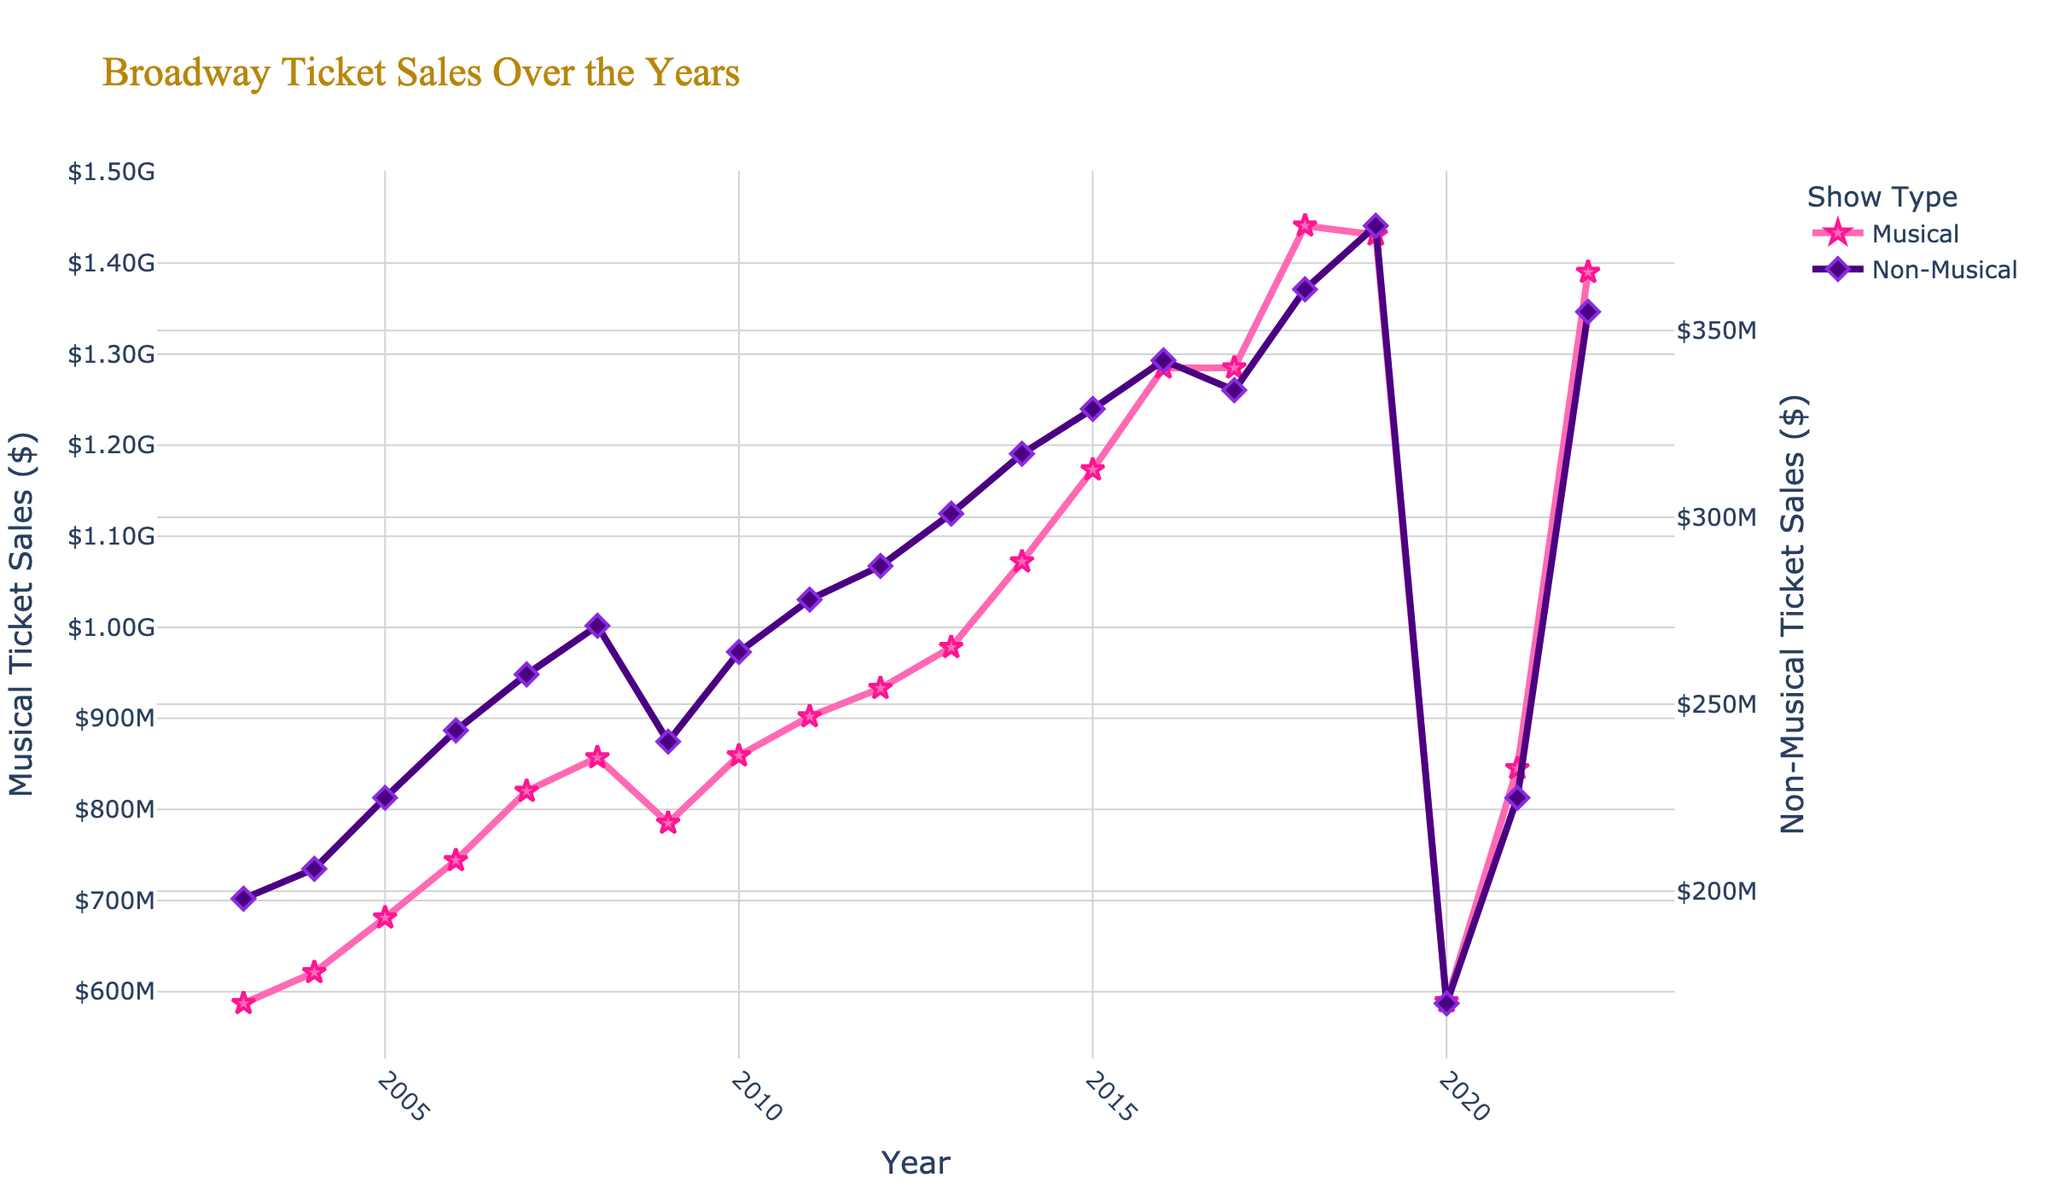What year did Musical Ticket Sales first exceed 1 billion dollars? Musical Ticket Sales reached over 1 billion dollars for the first time in 2014, as visualized on the plot. The line representing Musical Ticket Sales surpasses the 1 billion dollar mark in that year.
Answer: 2014 Between 2003 and 2022, which category, Musical or Non-Musical, had more consistent growth in ticket sales? Musical Ticket Sales show a more consistent upward trend compared to Non-Musical Ticket Sales. The line for musicals generally rises consistently throughout the years, while non-musical ticket sales have more fluctuations, including declines.
Answer: Musical By how much did Musical Ticket Sales decrease from 2019 to 2020, and was this decrease greater than the decrease in Non-Musical Ticket Sales during the same period? Musical Ticket Sales in 2019 were 1,431,000,000 dollars and dropped to 589,000,000 dollars in 2020. The decrease is 1,431,000,000 - 589,000,000 = 842,000,000 dollars. Non-Musical Ticket Sales in 2019 were 378,000,000 dollars and dropped to 170,000,000 dollars in 2020. The decrease is 378,000,000 - 170,000,000 = 208,000,000 dollars. The decrease in Musical Ticket Sales is significantly greater.
Answer: Yes, Musical decrease is greater by 634,000,000 What is the average annual Musical Ticket Sales from 2003 to 2022? Sum all Musical Ticket Sales from 2003 to 2022 and divide by the number of years. (587,000,000 + 621,000,000 + 681,000,000 + 744,000,000 + 820,000,000 + 857,000,000 + 785,000,000 + 859,000,000 + 902,000,000 + 933,000,000 + 978,000,000 + 1,072,000,000 + 1,173,000,000 + 1,285,000,000 + 1,285,000,000 + 1,441,000,000 + 1,431,000,000 + 589,000,000 + 845,000,000 + 1,390,000,000) / 20 = 963,050,000
Answer: 963,050,000 dollars per year How did the Musical and Non-Musical Ticket Sales compare in 2022? By looking at the values on the chart for the year 2022, Musical Ticket Sales were significantly higher at 1,390,000,000 dollars compared to Non-Musical Ticket Sales at 355,000,000 dollars.
Answer: Musical is roughly 4 times higher than Non-Musical Observe the change in Non-Musical Ticket Sales from 2020 to 2021. By what percentage did they increase? Non-Musical Ticket Sales in 2020 were 170,000,000 dollars and increased to 225,000,000 dollars in 2021. The percentage increase is calculated as ((225,000,000 - 170,000,000) / 170,000,000) * 100 = 32.35%
Answer: 32.35% Is there any year where Non-Musical Ticket Sales were greater than Musical Ticket Sales? If yes, which year? Observing the plot, there is no year where Non-Musical Ticket Sales surpass Musical Ticket Sales. The line for Musical Ticket Sales is always above the Non-Musical Ticket Sales line throughout all years.
Answer: No In which year did both Musical and Non-Musical ticket sales experience their most significant drop? Observing the largest drop in both lines concurrently is between 2019 and 2020. Both Musical and Non-Musical Ticket Sales saw their most significant drop during this period.
Answer: 2020 What is the trend observed in Musical Ticket Sales between 2016 and 2018? The line for Musical Ticket Sales shows an increasing trend between 2016 and 2018. Sales went from 1,285,000,000 dollars in 2016 to 1,441,000,000 dollars in 2018, indicating growth.
Answer: Increasing 